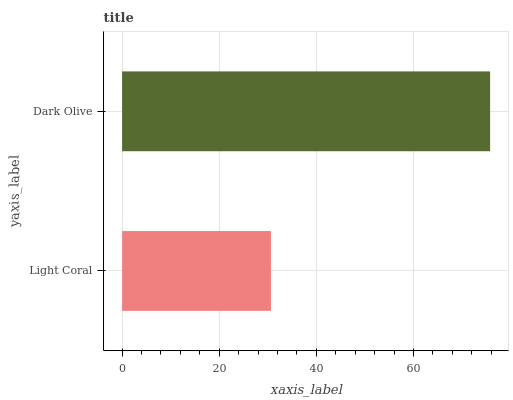Is Light Coral the minimum?
Answer yes or no. Yes. Is Dark Olive the maximum?
Answer yes or no. Yes. Is Dark Olive the minimum?
Answer yes or no. No. Is Dark Olive greater than Light Coral?
Answer yes or no. Yes. Is Light Coral less than Dark Olive?
Answer yes or no. Yes. Is Light Coral greater than Dark Olive?
Answer yes or no. No. Is Dark Olive less than Light Coral?
Answer yes or no. No. Is Dark Olive the high median?
Answer yes or no. Yes. Is Light Coral the low median?
Answer yes or no. Yes. Is Light Coral the high median?
Answer yes or no. No. Is Dark Olive the low median?
Answer yes or no. No. 